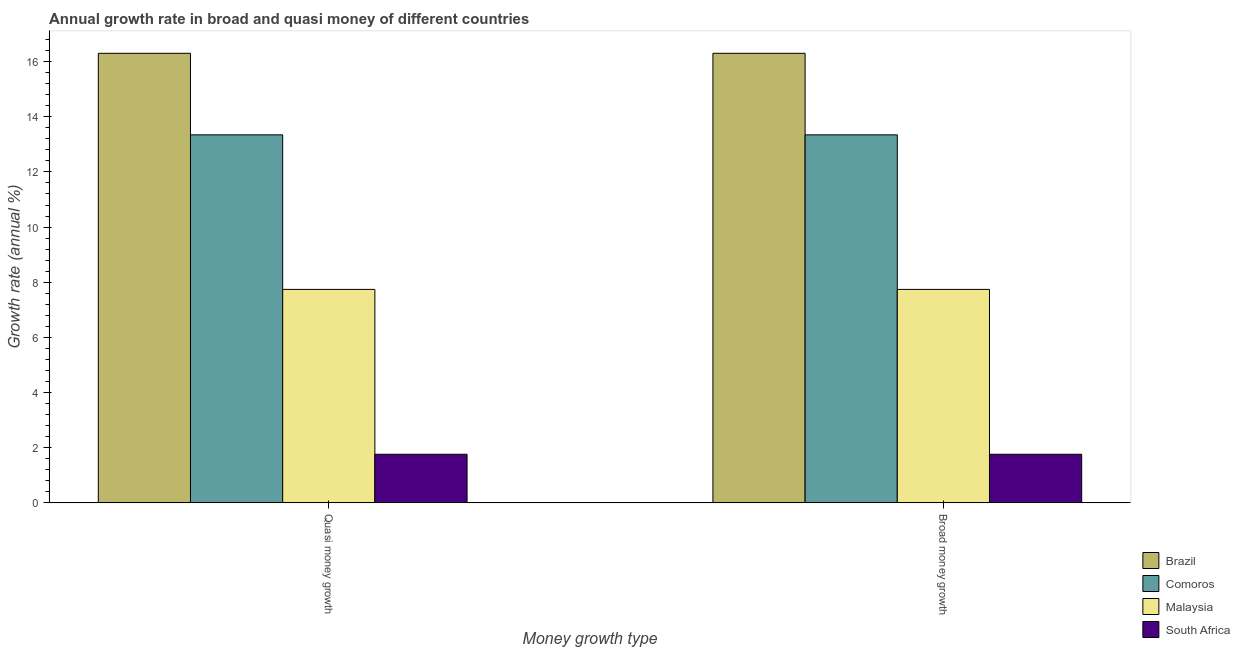How many different coloured bars are there?
Offer a terse response. 4. How many groups of bars are there?
Give a very brief answer. 2. Are the number of bars per tick equal to the number of legend labels?
Give a very brief answer. Yes. How many bars are there on the 1st tick from the left?
Provide a short and direct response. 4. How many bars are there on the 1st tick from the right?
Offer a terse response. 4. What is the label of the 1st group of bars from the left?
Provide a succinct answer. Quasi money growth. What is the annual growth rate in quasi money in South Africa?
Make the answer very short. 1.76. Across all countries, what is the maximum annual growth rate in quasi money?
Provide a short and direct response. 16.3. Across all countries, what is the minimum annual growth rate in quasi money?
Your answer should be very brief. 1.76. In which country was the annual growth rate in broad money minimum?
Offer a very short reply. South Africa. What is the total annual growth rate in broad money in the graph?
Offer a very short reply. 39.15. What is the difference between the annual growth rate in broad money in Comoros and that in Brazil?
Make the answer very short. -2.96. What is the difference between the annual growth rate in quasi money in Comoros and the annual growth rate in broad money in South Africa?
Ensure brevity in your answer.  11.58. What is the average annual growth rate in quasi money per country?
Your answer should be very brief. 9.79. What is the difference between the annual growth rate in quasi money and annual growth rate in broad money in South Africa?
Offer a terse response. 0. In how many countries, is the annual growth rate in quasi money greater than 2.4 %?
Offer a very short reply. 3. What is the ratio of the annual growth rate in broad money in Malaysia to that in Brazil?
Make the answer very short. 0.47. Is the annual growth rate in quasi money in Comoros less than that in Malaysia?
Your answer should be very brief. No. What does the 2nd bar from the right in Quasi money growth represents?
Offer a very short reply. Malaysia. Are all the bars in the graph horizontal?
Your answer should be compact. No. How many countries are there in the graph?
Give a very brief answer. 4. Are the values on the major ticks of Y-axis written in scientific E-notation?
Keep it short and to the point. No. How many legend labels are there?
Keep it short and to the point. 4. What is the title of the graph?
Make the answer very short. Annual growth rate in broad and quasi money of different countries. Does "Bangladesh" appear as one of the legend labels in the graph?
Keep it short and to the point. No. What is the label or title of the X-axis?
Offer a very short reply. Money growth type. What is the label or title of the Y-axis?
Keep it short and to the point. Growth rate (annual %). What is the Growth rate (annual %) in Brazil in Quasi money growth?
Make the answer very short. 16.3. What is the Growth rate (annual %) in Comoros in Quasi money growth?
Make the answer very short. 13.34. What is the Growth rate (annual %) of Malaysia in Quasi money growth?
Your response must be concise. 7.74. What is the Growth rate (annual %) in South Africa in Quasi money growth?
Ensure brevity in your answer.  1.76. What is the Growth rate (annual %) of Brazil in Broad money growth?
Offer a terse response. 16.3. What is the Growth rate (annual %) of Comoros in Broad money growth?
Offer a terse response. 13.34. What is the Growth rate (annual %) in Malaysia in Broad money growth?
Give a very brief answer. 7.74. What is the Growth rate (annual %) of South Africa in Broad money growth?
Offer a terse response. 1.76. Across all Money growth type, what is the maximum Growth rate (annual %) of Brazil?
Keep it short and to the point. 16.3. Across all Money growth type, what is the maximum Growth rate (annual %) in Comoros?
Make the answer very short. 13.34. Across all Money growth type, what is the maximum Growth rate (annual %) in Malaysia?
Give a very brief answer. 7.74. Across all Money growth type, what is the maximum Growth rate (annual %) in South Africa?
Give a very brief answer. 1.76. Across all Money growth type, what is the minimum Growth rate (annual %) of Brazil?
Make the answer very short. 16.3. Across all Money growth type, what is the minimum Growth rate (annual %) in Comoros?
Your answer should be very brief. 13.34. Across all Money growth type, what is the minimum Growth rate (annual %) of Malaysia?
Provide a short and direct response. 7.74. Across all Money growth type, what is the minimum Growth rate (annual %) of South Africa?
Make the answer very short. 1.76. What is the total Growth rate (annual %) of Brazil in the graph?
Give a very brief answer. 32.6. What is the total Growth rate (annual %) of Comoros in the graph?
Make the answer very short. 26.69. What is the total Growth rate (annual %) in Malaysia in the graph?
Your answer should be compact. 15.48. What is the total Growth rate (annual %) of South Africa in the graph?
Give a very brief answer. 3.52. What is the difference between the Growth rate (annual %) in Brazil in Quasi money growth and that in Broad money growth?
Ensure brevity in your answer.  0. What is the difference between the Growth rate (annual %) in Malaysia in Quasi money growth and that in Broad money growth?
Ensure brevity in your answer.  0. What is the difference between the Growth rate (annual %) in Brazil in Quasi money growth and the Growth rate (annual %) in Comoros in Broad money growth?
Keep it short and to the point. 2.96. What is the difference between the Growth rate (annual %) of Brazil in Quasi money growth and the Growth rate (annual %) of Malaysia in Broad money growth?
Provide a succinct answer. 8.56. What is the difference between the Growth rate (annual %) in Brazil in Quasi money growth and the Growth rate (annual %) in South Africa in Broad money growth?
Your answer should be compact. 14.54. What is the difference between the Growth rate (annual %) of Comoros in Quasi money growth and the Growth rate (annual %) of Malaysia in Broad money growth?
Make the answer very short. 5.6. What is the difference between the Growth rate (annual %) in Comoros in Quasi money growth and the Growth rate (annual %) in South Africa in Broad money growth?
Offer a terse response. 11.58. What is the difference between the Growth rate (annual %) of Malaysia in Quasi money growth and the Growth rate (annual %) of South Africa in Broad money growth?
Provide a short and direct response. 5.98. What is the average Growth rate (annual %) of Brazil per Money growth type?
Offer a very short reply. 16.3. What is the average Growth rate (annual %) of Comoros per Money growth type?
Provide a succinct answer. 13.34. What is the average Growth rate (annual %) of Malaysia per Money growth type?
Your response must be concise. 7.74. What is the average Growth rate (annual %) in South Africa per Money growth type?
Your answer should be very brief. 1.76. What is the difference between the Growth rate (annual %) in Brazil and Growth rate (annual %) in Comoros in Quasi money growth?
Your response must be concise. 2.96. What is the difference between the Growth rate (annual %) in Brazil and Growth rate (annual %) in Malaysia in Quasi money growth?
Provide a succinct answer. 8.56. What is the difference between the Growth rate (annual %) of Brazil and Growth rate (annual %) of South Africa in Quasi money growth?
Your response must be concise. 14.54. What is the difference between the Growth rate (annual %) in Comoros and Growth rate (annual %) in Malaysia in Quasi money growth?
Give a very brief answer. 5.6. What is the difference between the Growth rate (annual %) of Comoros and Growth rate (annual %) of South Africa in Quasi money growth?
Make the answer very short. 11.58. What is the difference between the Growth rate (annual %) of Malaysia and Growth rate (annual %) of South Africa in Quasi money growth?
Offer a very short reply. 5.98. What is the difference between the Growth rate (annual %) of Brazil and Growth rate (annual %) of Comoros in Broad money growth?
Your answer should be compact. 2.96. What is the difference between the Growth rate (annual %) of Brazil and Growth rate (annual %) of Malaysia in Broad money growth?
Provide a short and direct response. 8.56. What is the difference between the Growth rate (annual %) in Brazil and Growth rate (annual %) in South Africa in Broad money growth?
Give a very brief answer. 14.54. What is the difference between the Growth rate (annual %) of Comoros and Growth rate (annual %) of Malaysia in Broad money growth?
Your answer should be compact. 5.6. What is the difference between the Growth rate (annual %) of Comoros and Growth rate (annual %) of South Africa in Broad money growth?
Offer a very short reply. 11.58. What is the difference between the Growth rate (annual %) of Malaysia and Growth rate (annual %) of South Africa in Broad money growth?
Provide a succinct answer. 5.98. What is the ratio of the Growth rate (annual %) of Comoros in Quasi money growth to that in Broad money growth?
Ensure brevity in your answer.  1. What is the ratio of the Growth rate (annual %) of Malaysia in Quasi money growth to that in Broad money growth?
Your answer should be compact. 1. What is the ratio of the Growth rate (annual %) in South Africa in Quasi money growth to that in Broad money growth?
Keep it short and to the point. 1. What is the difference between the highest and the second highest Growth rate (annual %) of Brazil?
Offer a terse response. 0. What is the difference between the highest and the second highest Growth rate (annual %) of South Africa?
Ensure brevity in your answer.  0. What is the difference between the highest and the lowest Growth rate (annual %) of Malaysia?
Give a very brief answer. 0. What is the difference between the highest and the lowest Growth rate (annual %) of South Africa?
Your answer should be compact. 0. 